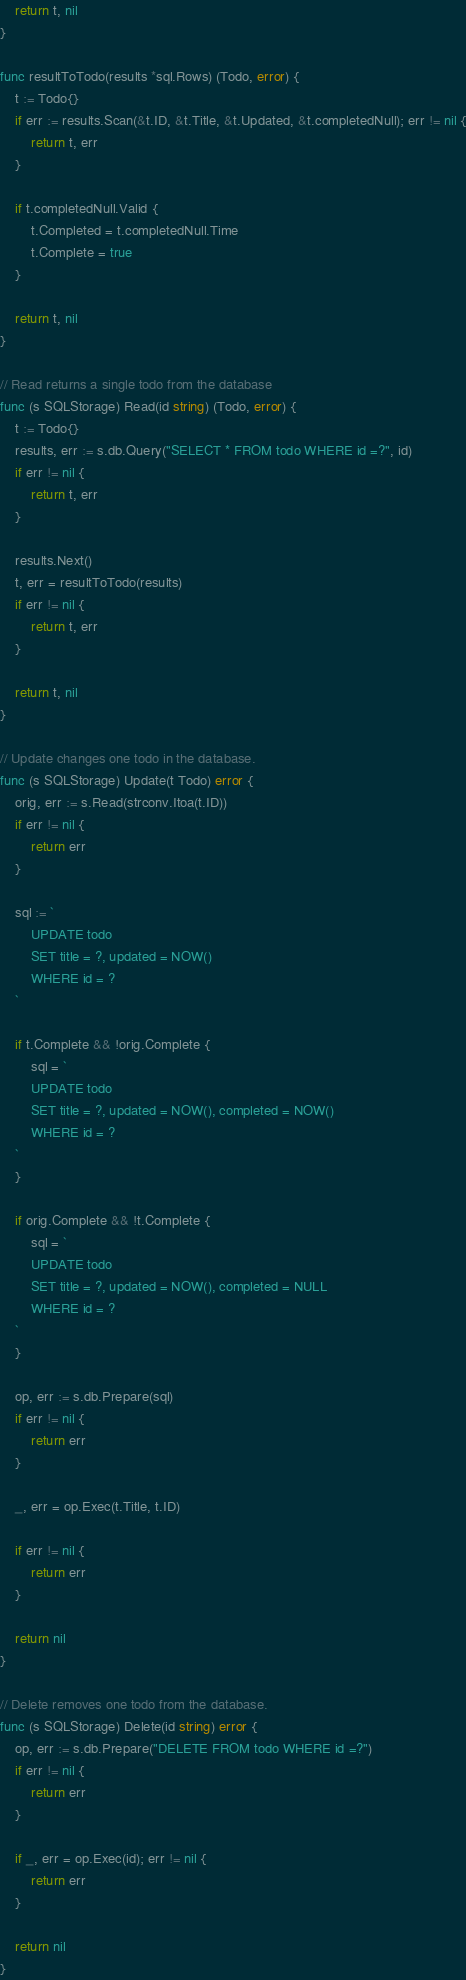Convert code to text. <code><loc_0><loc_0><loc_500><loc_500><_Go_>
	return t, nil
}

func resultToTodo(results *sql.Rows) (Todo, error) {
	t := Todo{}
	if err := results.Scan(&t.ID, &t.Title, &t.Updated, &t.completedNull); err != nil {
		return t, err
	}

	if t.completedNull.Valid {
		t.Completed = t.completedNull.Time
		t.Complete = true
	}

	return t, nil
}

// Read returns a single todo from the database
func (s SQLStorage) Read(id string) (Todo, error) {
	t := Todo{}
	results, err := s.db.Query("SELECT * FROM todo WHERE id =?", id)
	if err != nil {
		return t, err
	}

	results.Next()
	t, err = resultToTodo(results)
	if err != nil {
		return t, err
	}

	return t, nil
}

// Update changes one todo in the database.
func (s SQLStorage) Update(t Todo) error {
	orig, err := s.Read(strconv.Itoa(t.ID))
	if err != nil {
		return err
	}

	sql := `
		UPDATE todo
		SET title = ?, updated = NOW() 
		WHERE id = ?
	`

	if t.Complete && !orig.Complete {
		sql = `
		UPDATE todo
		SET title = ?, updated = NOW(), completed = NOW() 
		WHERE id = ?
	`
	}

	if orig.Complete && !t.Complete {
		sql = `
		UPDATE todo
		SET title = ?, updated = NOW(), completed = NULL 
		WHERE id = ?
	`
	}

	op, err := s.db.Prepare(sql)
	if err != nil {
		return err
	}

	_, err = op.Exec(t.Title, t.ID)

	if err != nil {
		return err
	}

	return nil
}

// Delete removes one todo from the database.
func (s SQLStorage) Delete(id string) error {
	op, err := s.db.Prepare("DELETE FROM todo WHERE id =?")
	if err != nil {
		return err
	}

	if _, err = op.Exec(id); err != nil {
		return err
	}

	return nil
}
</code> 